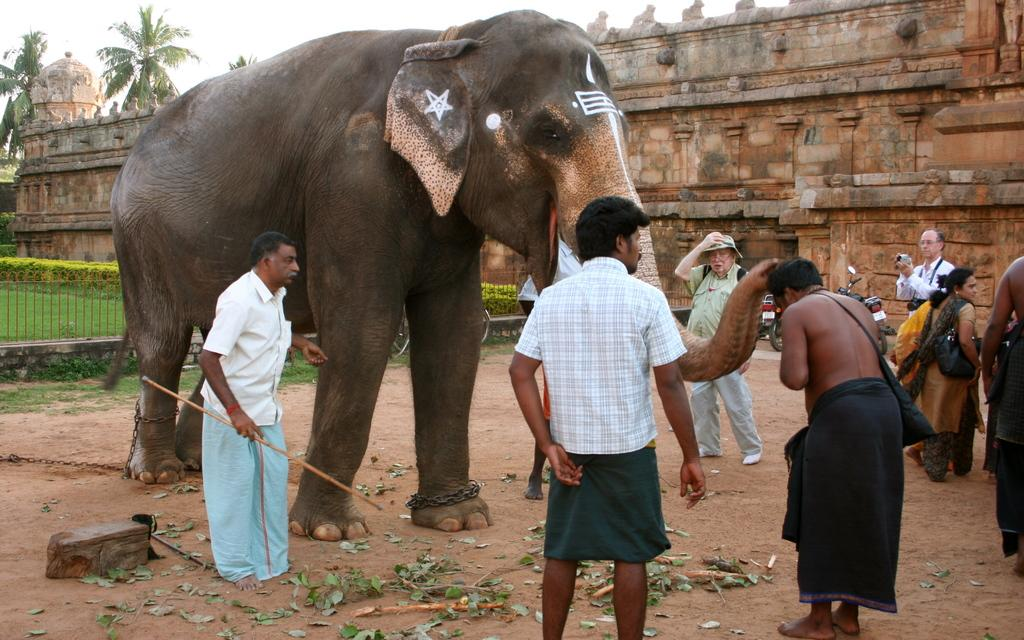What type of structure is visible in the image? There is a building in the image. What other natural elements can be seen in the image? There are trees in the image. What animal is present in the image? There is an elephant in the image. What are the people in the image doing? There are people standing around the elephant. What activity is being performed by one of the people in the image? A person is taking a photograph in the image. How much salt is present on the elephant's back in the image? There is no salt present on the elephant's back in the image. What type of regret is being expressed by the people standing around the elephant? There is no indication of regret being expressed by the people in the image. 